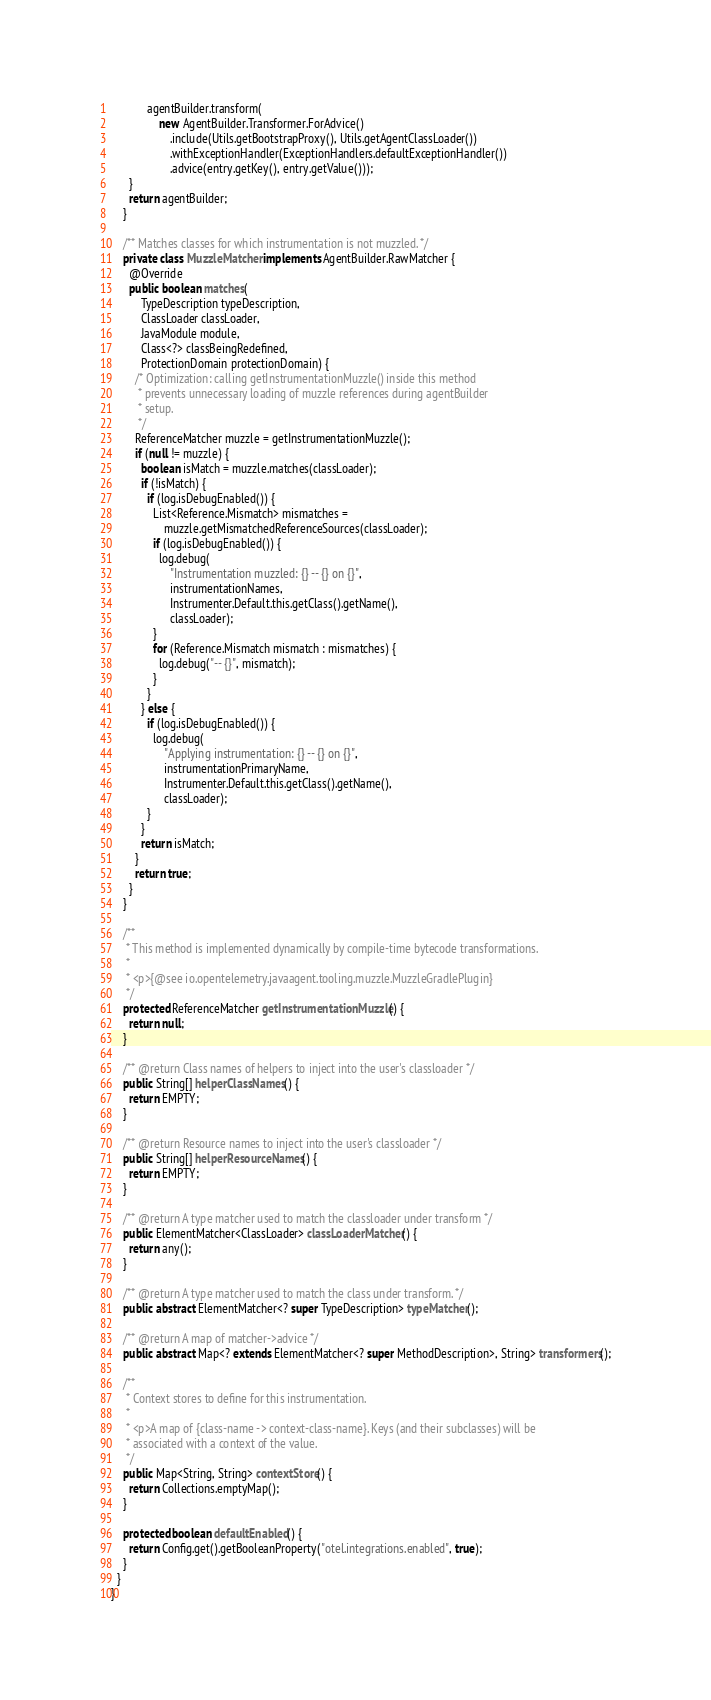Convert code to text. <code><loc_0><loc_0><loc_500><loc_500><_Java_>            agentBuilder.transform(
                new AgentBuilder.Transformer.ForAdvice()
                    .include(Utils.getBootstrapProxy(), Utils.getAgentClassLoader())
                    .withExceptionHandler(ExceptionHandlers.defaultExceptionHandler())
                    .advice(entry.getKey(), entry.getValue()));
      }
      return agentBuilder;
    }

    /** Matches classes for which instrumentation is not muzzled. */
    private class MuzzleMatcher implements AgentBuilder.RawMatcher {
      @Override
      public boolean matches(
          TypeDescription typeDescription,
          ClassLoader classLoader,
          JavaModule module,
          Class<?> classBeingRedefined,
          ProtectionDomain protectionDomain) {
        /* Optimization: calling getInstrumentationMuzzle() inside this method
         * prevents unnecessary loading of muzzle references during agentBuilder
         * setup.
         */
        ReferenceMatcher muzzle = getInstrumentationMuzzle();
        if (null != muzzle) {
          boolean isMatch = muzzle.matches(classLoader);
          if (!isMatch) {
            if (log.isDebugEnabled()) {
              List<Reference.Mismatch> mismatches =
                  muzzle.getMismatchedReferenceSources(classLoader);
              if (log.isDebugEnabled()) {
                log.debug(
                    "Instrumentation muzzled: {} -- {} on {}",
                    instrumentationNames,
                    Instrumenter.Default.this.getClass().getName(),
                    classLoader);
              }
              for (Reference.Mismatch mismatch : mismatches) {
                log.debug("-- {}", mismatch);
              }
            }
          } else {
            if (log.isDebugEnabled()) {
              log.debug(
                  "Applying instrumentation: {} -- {} on {}",
                  instrumentationPrimaryName,
                  Instrumenter.Default.this.getClass().getName(),
                  classLoader);
            }
          }
          return isMatch;
        }
        return true;
      }
    }

    /**
     * This method is implemented dynamically by compile-time bytecode transformations.
     *
     * <p>{@see io.opentelemetry.javaagent.tooling.muzzle.MuzzleGradlePlugin}
     */
    protected ReferenceMatcher getInstrumentationMuzzle() {
      return null;
    }

    /** @return Class names of helpers to inject into the user's classloader */
    public String[] helperClassNames() {
      return EMPTY;
    }

    /** @return Resource names to inject into the user's classloader */
    public String[] helperResourceNames() {
      return EMPTY;
    }

    /** @return A type matcher used to match the classloader under transform */
    public ElementMatcher<ClassLoader> classLoaderMatcher() {
      return any();
    }

    /** @return A type matcher used to match the class under transform. */
    public abstract ElementMatcher<? super TypeDescription> typeMatcher();

    /** @return A map of matcher->advice */
    public abstract Map<? extends ElementMatcher<? super MethodDescription>, String> transformers();

    /**
     * Context stores to define for this instrumentation.
     *
     * <p>A map of {class-name -> context-class-name}. Keys (and their subclasses) will be
     * associated with a context of the value.
     */
    public Map<String, String> contextStore() {
      return Collections.emptyMap();
    }

    protected boolean defaultEnabled() {
      return Config.get().getBooleanProperty("otel.integrations.enabled", true);
    }
  }
}
</code> 